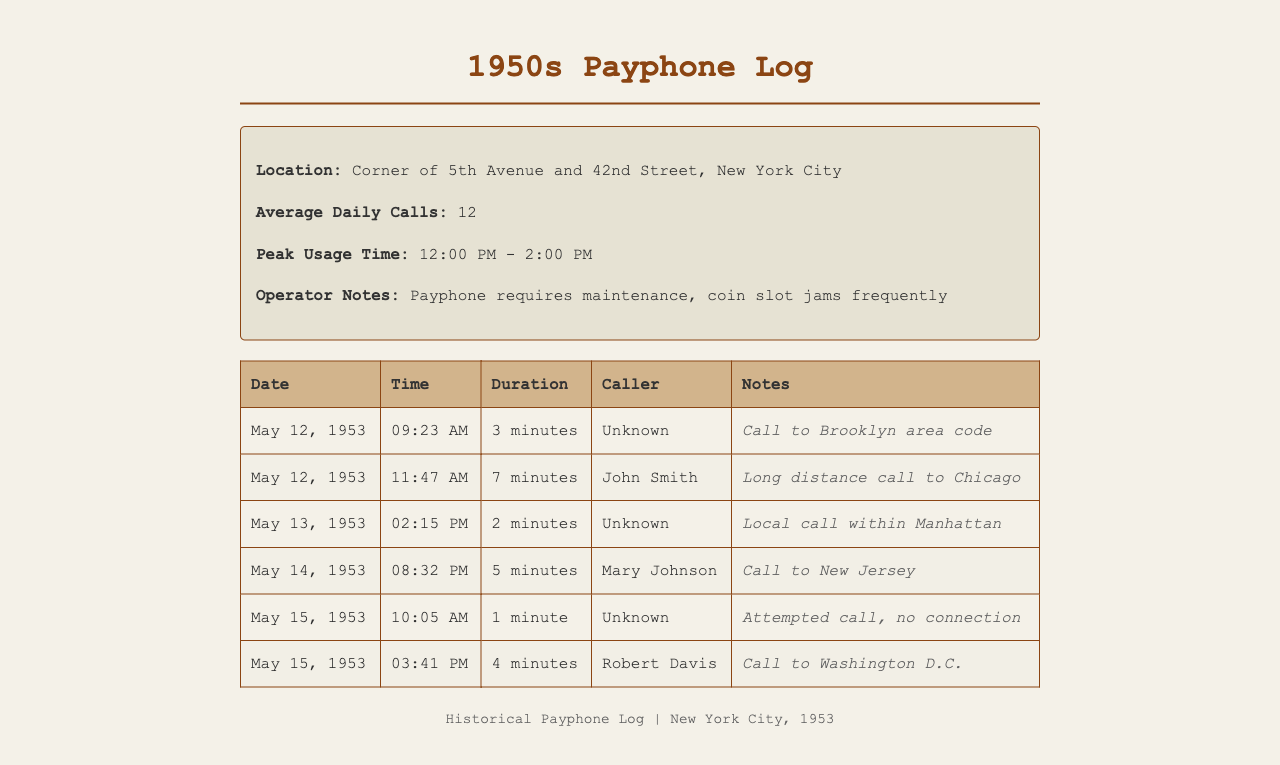what is the location of the payphone? The payphone is located at the corner of 5th Avenue and 42nd Street in New York City.
Answer: Corner of 5th Avenue and 42nd Street, New York City what is the average number of daily calls? The average daily calls logged from the payphone is provided in the document.
Answer: 12 who made the long-distance call to Chicago? The long-distance call to Chicago was made by John Smith, as noted in the records.
Answer: John Smith what was the duration of the call made by Mary Johnson? The duration of the call made by Mary Johnson can be found in the call log of the document.
Answer: 5 minutes how many minutes was the call to the Brooklyn area code? The duration of the call to the Brooklyn area code is detailed in the log.
Answer: 3 minutes what time was the longest call recorded? To find the longest call recorded, we need to identify the call with the maximum duration in the list.
Answer: 11:47 AM what is the operator's note about the payphone? The operator's note gives insights into issues with the payphone as logged in the document.
Answer: Payphone requires maintenance, coin slot jams frequently which call attempt had no connection? The document specifies a call attempt that resulted in no connection through the logs.
Answer: Unknown what was the date of the call to New Jersey? The date for the call to New Jersey is documented within the call records.
Answer: May 14, 1953 